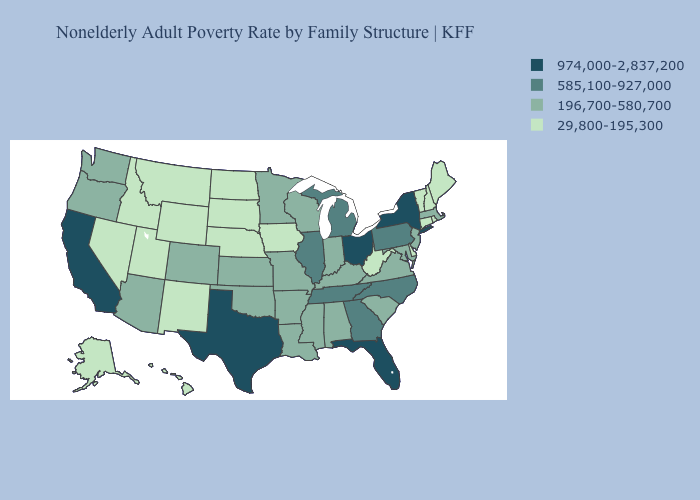What is the value of Michigan?
Answer briefly. 585,100-927,000. Among the states that border Massachusetts , does Rhode Island have the highest value?
Be succinct. No. Name the states that have a value in the range 29,800-195,300?
Quick response, please. Alaska, Connecticut, Delaware, Hawaii, Idaho, Iowa, Maine, Montana, Nebraska, Nevada, New Hampshire, New Mexico, North Dakota, Rhode Island, South Dakota, Utah, Vermont, West Virginia, Wyoming. What is the value of Washington?
Quick response, please. 196,700-580,700. Does Idaho have a higher value than Iowa?
Quick response, please. No. Among the states that border Illinois , does Iowa have the highest value?
Answer briefly. No. What is the highest value in the USA?
Keep it brief. 974,000-2,837,200. Name the states that have a value in the range 29,800-195,300?
Keep it brief. Alaska, Connecticut, Delaware, Hawaii, Idaho, Iowa, Maine, Montana, Nebraska, Nevada, New Hampshire, New Mexico, North Dakota, Rhode Island, South Dakota, Utah, Vermont, West Virginia, Wyoming. Name the states that have a value in the range 585,100-927,000?
Answer briefly. Georgia, Illinois, Michigan, North Carolina, Pennsylvania, Tennessee. Name the states that have a value in the range 196,700-580,700?
Answer briefly. Alabama, Arizona, Arkansas, Colorado, Indiana, Kansas, Kentucky, Louisiana, Maryland, Massachusetts, Minnesota, Mississippi, Missouri, New Jersey, Oklahoma, Oregon, South Carolina, Virginia, Washington, Wisconsin. What is the lowest value in the South?
Be succinct. 29,800-195,300. Among the states that border New Jersey , which have the highest value?
Be succinct. New York. What is the lowest value in the USA?
Short answer required. 29,800-195,300. Which states have the lowest value in the South?
Give a very brief answer. Delaware, West Virginia. Which states have the highest value in the USA?
Quick response, please. California, Florida, New York, Ohio, Texas. 